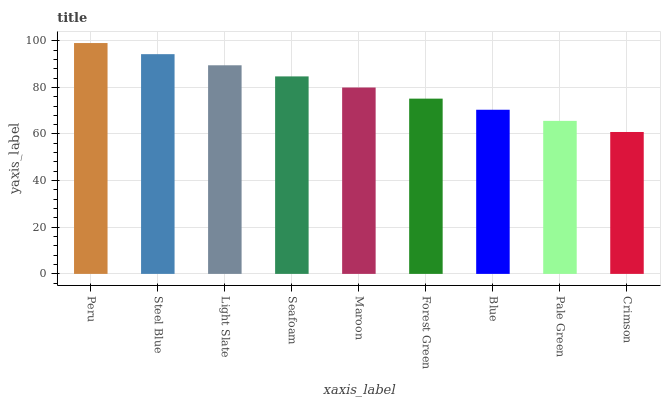Is Crimson the minimum?
Answer yes or no. Yes. Is Peru the maximum?
Answer yes or no. Yes. Is Steel Blue the minimum?
Answer yes or no. No. Is Steel Blue the maximum?
Answer yes or no. No. Is Peru greater than Steel Blue?
Answer yes or no. Yes. Is Steel Blue less than Peru?
Answer yes or no. Yes. Is Steel Blue greater than Peru?
Answer yes or no. No. Is Peru less than Steel Blue?
Answer yes or no. No. Is Maroon the high median?
Answer yes or no. Yes. Is Maroon the low median?
Answer yes or no. Yes. Is Blue the high median?
Answer yes or no. No. Is Seafoam the low median?
Answer yes or no. No. 